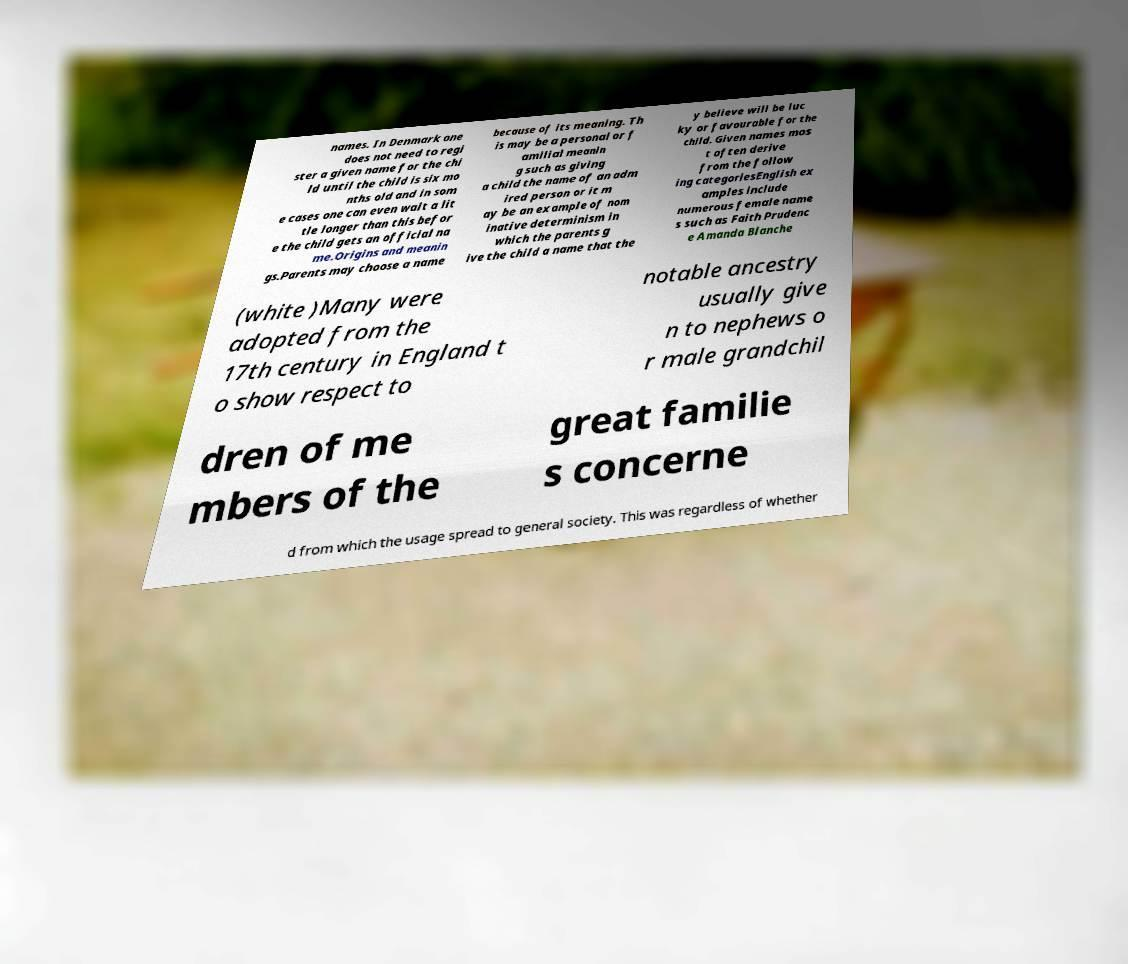Can you read and provide the text displayed in the image?This photo seems to have some interesting text. Can you extract and type it out for me? names. In Denmark one does not need to regi ster a given name for the chi ld until the child is six mo nths old and in som e cases one can even wait a lit tle longer than this befor e the child gets an official na me.Origins and meanin gs.Parents may choose a name because of its meaning. Th is may be a personal or f amilial meanin g such as giving a child the name of an adm ired person or it m ay be an example of nom inative determinism in which the parents g ive the child a name that the y believe will be luc ky or favourable for the child. Given names mos t often derive from the follow ing categoriesEnglish ex amples include numerous female name s such as Faith Prudenc e Amanda Blanche (white )Many were adopted from the 17th century in England t o show respect to notable ancestry usually give n to nephews o r male grandchil dren of me mbers of the great familie s concerne d from which the usage spread to general society. This was regardless of whether 